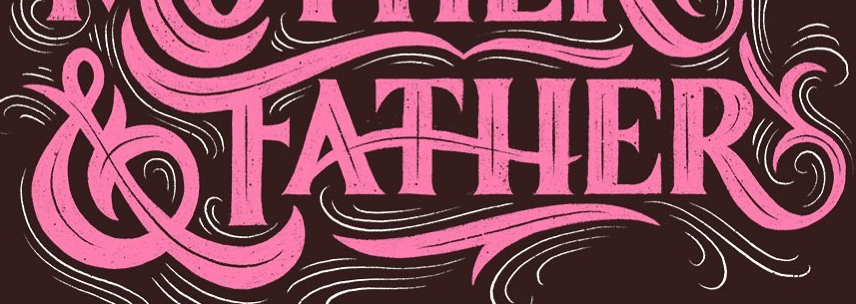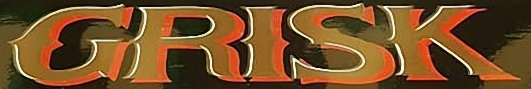What words are shown in these images in order, separated by a semicolon? &FATHER; GRISK 